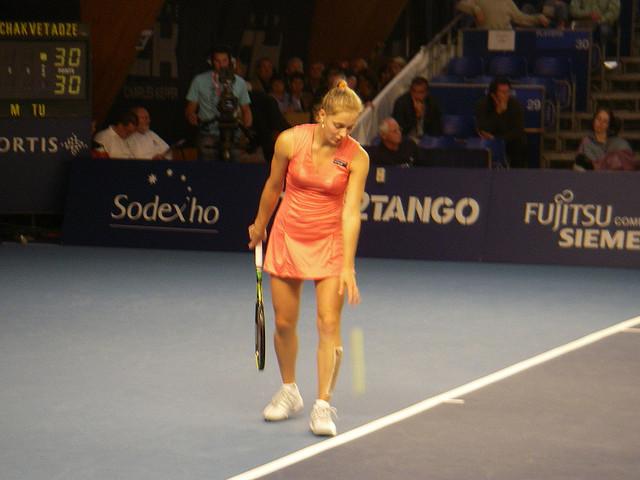Why is she standing on one leg?
Quick response, please. To serve. What do the people in orange do?
Quick response, please. Play tennis. What sport is she playing?
Keep it brief. Tennis. What color is her dress?
Give a very brief answer. Orange. What company is on the left side of the girl?
Quick response, please. Sodexho. 